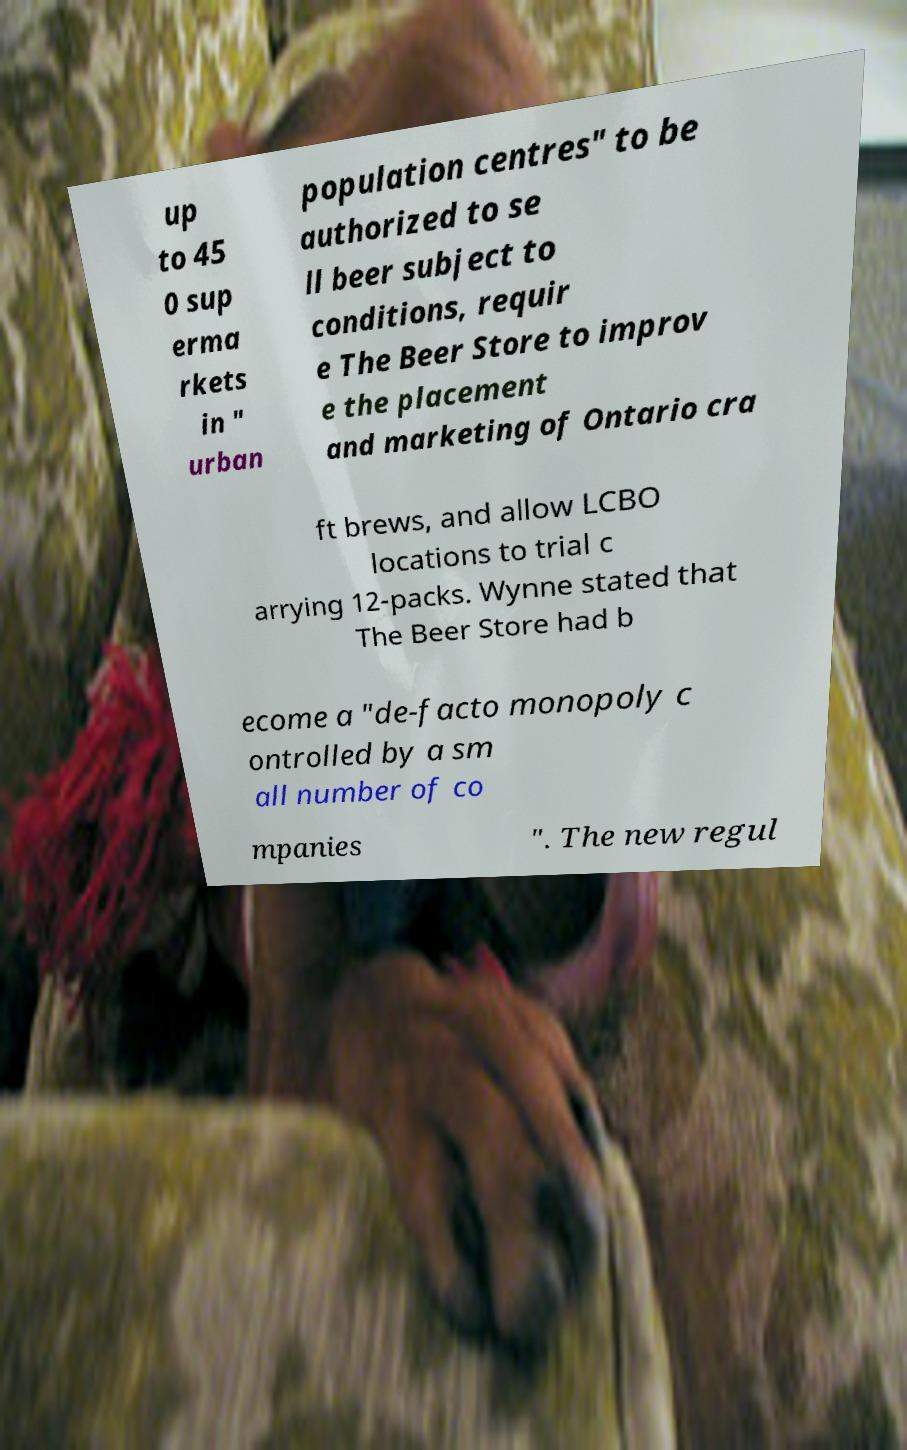Can you accurately transcribe the text from the provided image for me? up to 45 0 sup erma rkets in " urban population centres" to be authorized to se ll beer subject to conditions, requir e The Beer Store to improv e the placement and marketing of Ontario cra ft brews, and allow LCBO locations to trial c arrying 12-packs. Wynne stated that The Beer Store had b ecome a "de-facto monopoly c ontrolled by a sm all number of co mpanies ". The new regul 